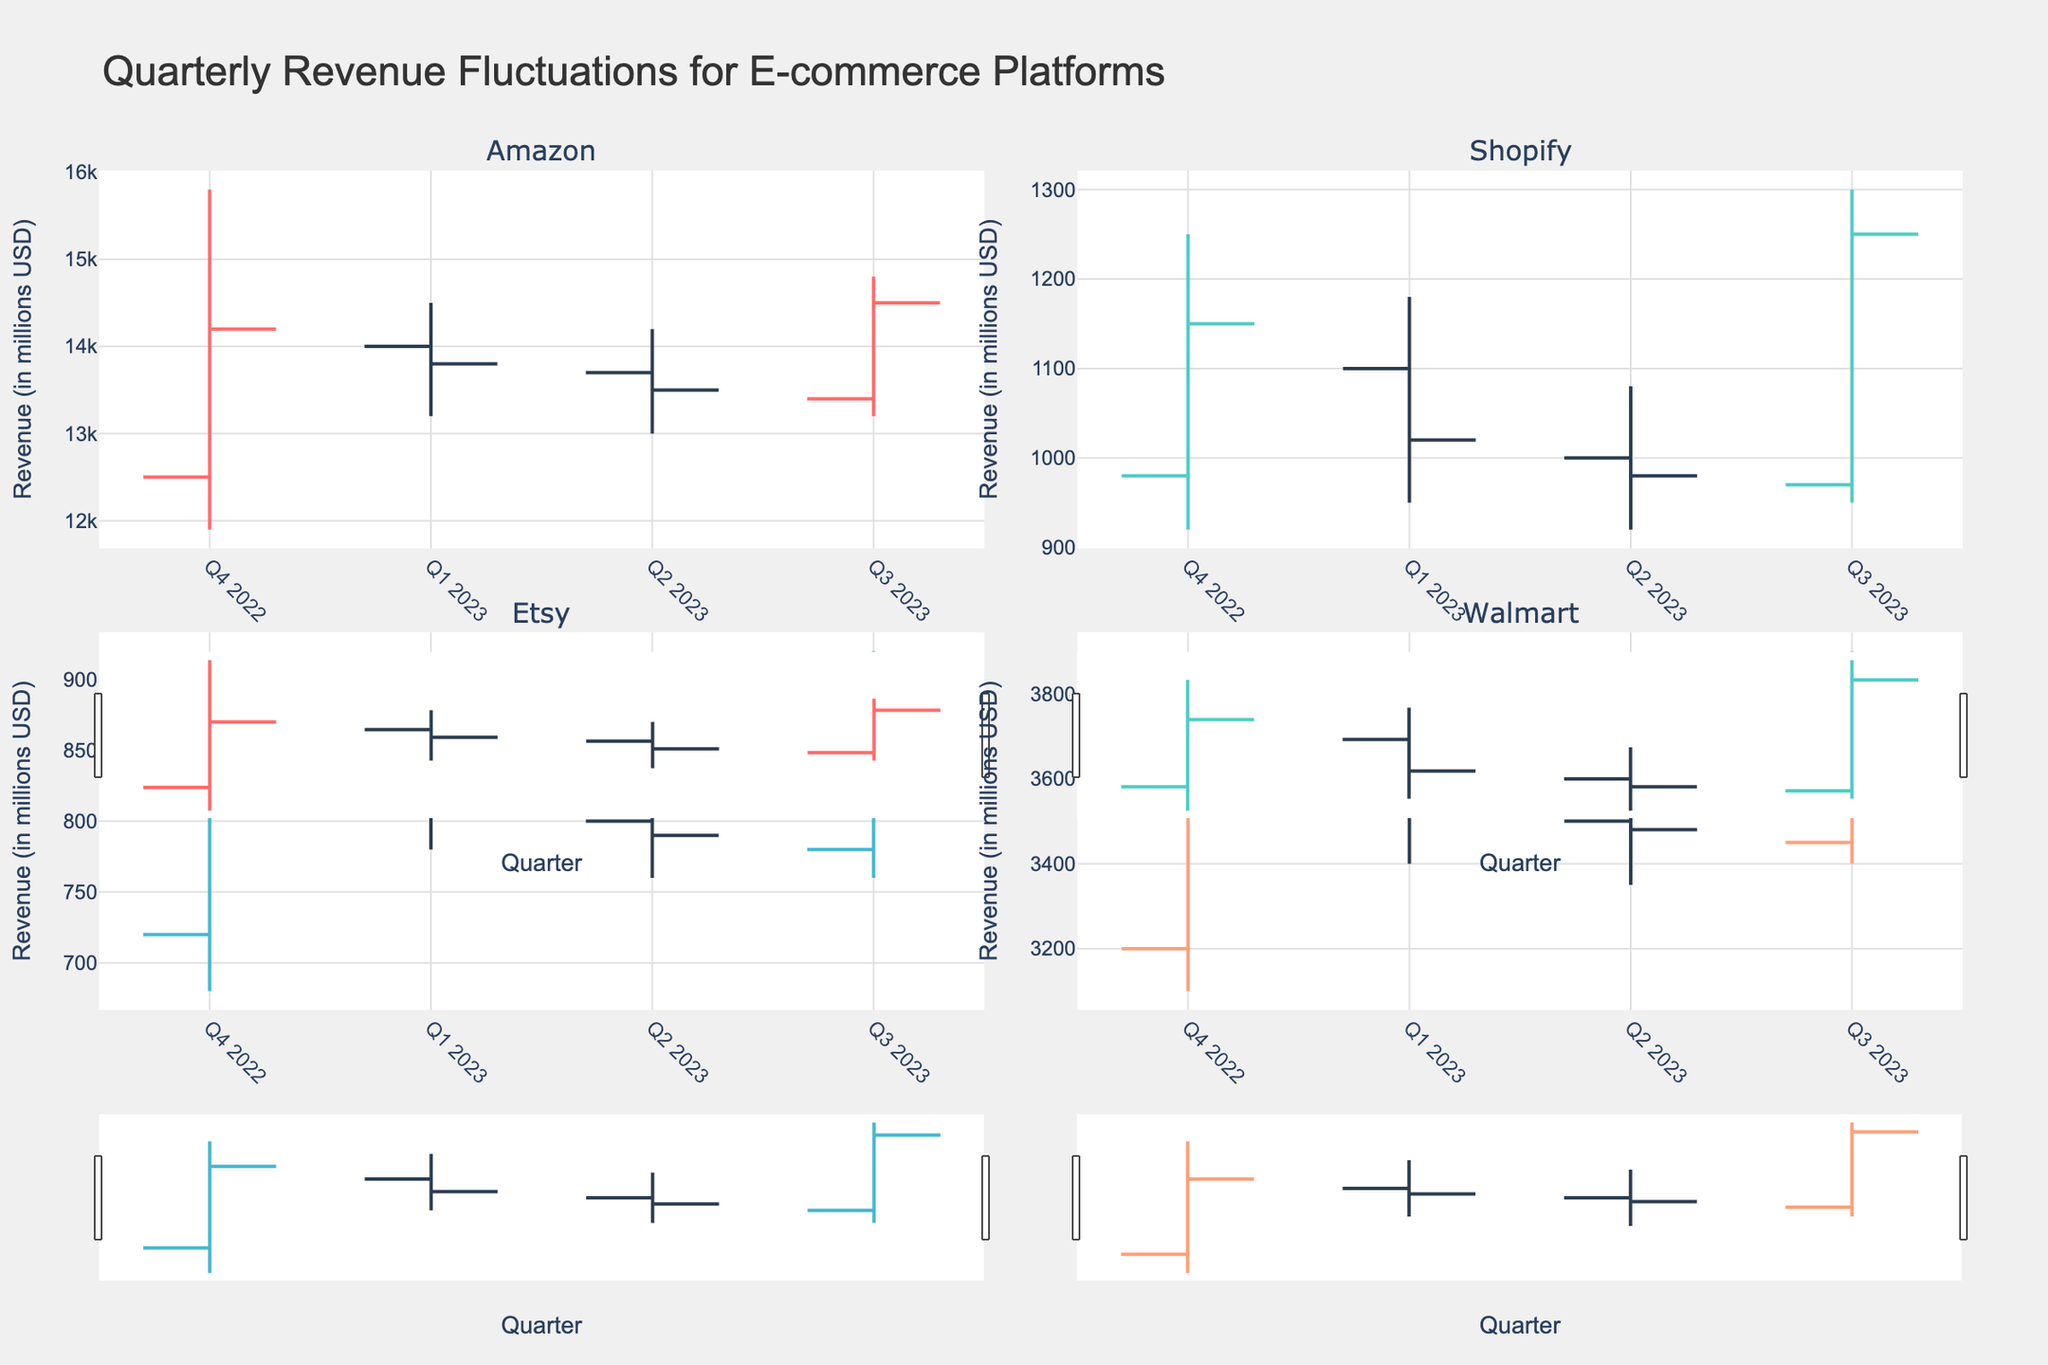How is the **open price** of Amazon in Q4 2022 compared to Q3 2023? The open price for Amazon in Q4 2022 (which is 12,500) versus the open price in Q3 2023 (which is 13,400) shows that the open price increased from Q4 2022 to Q3 2023.
Answer: Increased Which quarter shows the **highest close price** for Walmart? The close prices for Walmart across the quarters are: Q4 2022: 3,600; Q1 2023: 3,520; Q2 2023: 3,480; Q3 2023: 3,850. The quarter with the highest close price is Q3 2023.
Answer: Q3 2023 What's the **average close price** of Shopify across all quarters? The close prices for Shopify are: 1,150, 1,020, 980, 1,250. The average would be calculated as (1,150 + 1,020 + 980 + 1,250) / 4 = 4,400 / 4 = 1,100.
Answer: 1,100 Which platform had the **most significant drop in revenue** over a single quarter? The most significant drop can be determined by finding the difference between high and low values. Calculate these differences for each platform in each quarter and compare. Etsy in Q4 2022 had a high of 890 and a low of 680, resulting in a significant drop of 210 units.
Answer: Etsy in Q4 2022 Does Etsy show any quarters where the **open price was higher than the close price**? If yes, which ones? Check the open and close prices for Etsy for each quarter. Q4 2022 (open: 720, close: 850), Q1 2023 (open: 830, close: 810), Q2 2023 (open: 800, close: 790), Q3 2023 (open: 780, close: 900). Q1 2023 and Q2 2023 show the open price higher than the close price.
Answer: Q1 2023 and Q2 2023 For Amazon, which quarter shows the **smallest fluctuation** between high and low prices? Calculate the difference between high and low prices for each quarter for Amazon. Q4 2022: (15800 - 11900 = 3900), Q1 2023: (14500 - 13200 = 1300), Q2 2023: (14200 - 13000 = 1200), Q3 2023: (14800 - 13200 = 1600). The smallest fluctuation is in Q2 2023.
Answer: Q2 2023 Which platform had the **most stable revenue** in Q1 2023 based on the close price's proximity to the open price? Compare the open and close prices' proximity for each platform in Q1 2023. Amazon: (14000 - 13800 = 200), Shopify: (1100 - 1020 = 80), Etsy: (830 - 810 = 20), Walmart: (3550 - 3520 = 30). Etsy had the most stable revenue as the difference is the smallest.
Answer: Etsy What is the **trend of the close prices** for Walmart from Q4 2022 to Q3 2023? Compare close prices sequentially: Q4 2022: 3,600, Q1 2023: 3,520, Q2 2023: 3,480, Q3 2023: 3,850. The trend shows a decrease from Q4 2022 to Q2 2023 followed by an increase in Q3 2023.
Answer: Decreasing then increasing 